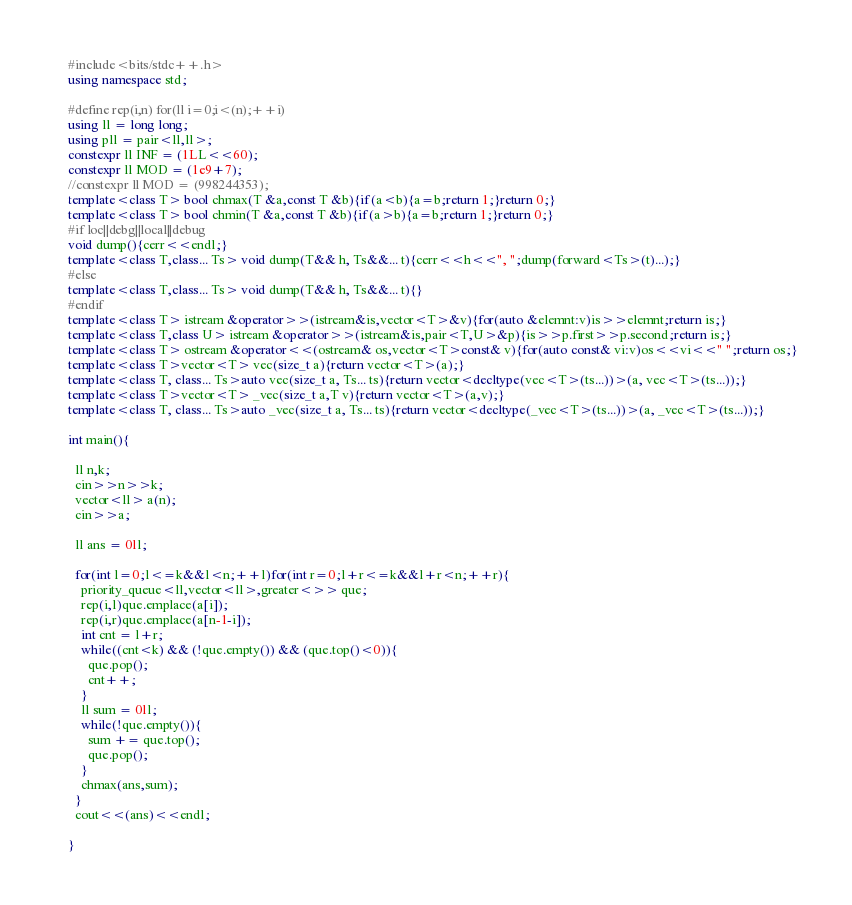<code> <loc_0><loc_0><loc_500><loc_500><_C++_>#include<bits/stdc++.h>
using namespace std;

#define rep(i,n) for(ll i=0;i<(n);++i)
using ll = long long;
using pll = pair<ll,ll>;
constexpr ll INF = (1LL<<60);
constexpr ll MOD = (1e9+7);
//constexpr ll MOD = (998244353);
template<class T> bool chmax(T &a,const T &b){if(a<b){a=b;return 1;}return 0;}
template<class T> bool chmin(T &a,const T &b){if(a>b){a=b;return 1;}return 0;}
#if loc||debg||local||debug
void dump(){cerr<<endl;}
template<class T,class... Ts> void dump(T&& h, Ts&&... t){cerr<<h<<", ";dump(forward<Ts>(t)...);}
#else
template<class T,class... Ts> void dump(T&& h, Ts&&... t){}
#endif
template<class T> istream &operator>>(istream&is,vector<T>&v){for(auto &elemnt:v)is>>elemnt;return is;}
template<class T,class U> istream &operator>>(istream&is,pair<T,U>&p){is>>p.first>>p.second;return is;}
template<class T> ostream &operator<<(ostream& os,vector<T>const& v){for(auto const& vi:v)os<<vi<<" ";return os;}
template<class T>vector<T> vec(size_t a){return vector<T>(a);}
template<class T, class... Ts>auto vec(size_t a, Ts... ts){return vector<decltype(vec<T>(ts...))>(a, vec<T>(ts...));}
template<class T>vector<T> _vec(size_t a,T v){return vector<T>(a,v);}
template<class T, class... Ts>auto _vec(size_t a, Ts... ts){return vector<decltype(_vec<T>(ts...))>(a, _vec<T>(ts...));}

int main(){

  ll n,k;
  cin>>n>>k;
  vector<ll> a(n);
  cin>>a;

  ll ans = 0ll;

  for(int l=0;l<=k&&l<n;++l)for(int r=0;l+r<=k&&l+r<n;++r){
    priority_queue<ll,vector<ll>,greater<>> que;
    rep(i,l)que.emplace(a[i]);
    rep(i,r)que.emplace(a[n-1-i]);
    int cnt = l+r;
    while((cnt<k) && (!que.empty()) && (que.top()<0)){
      que.pop();
      cnt++;
    }
    ll sum = 0ll;
    while(!que.empty()){
      sum += que.top();
      que.pop();
    }
    chmax(ans,sum);
  }
  cout<<(ans)<<endl;

}</code> 